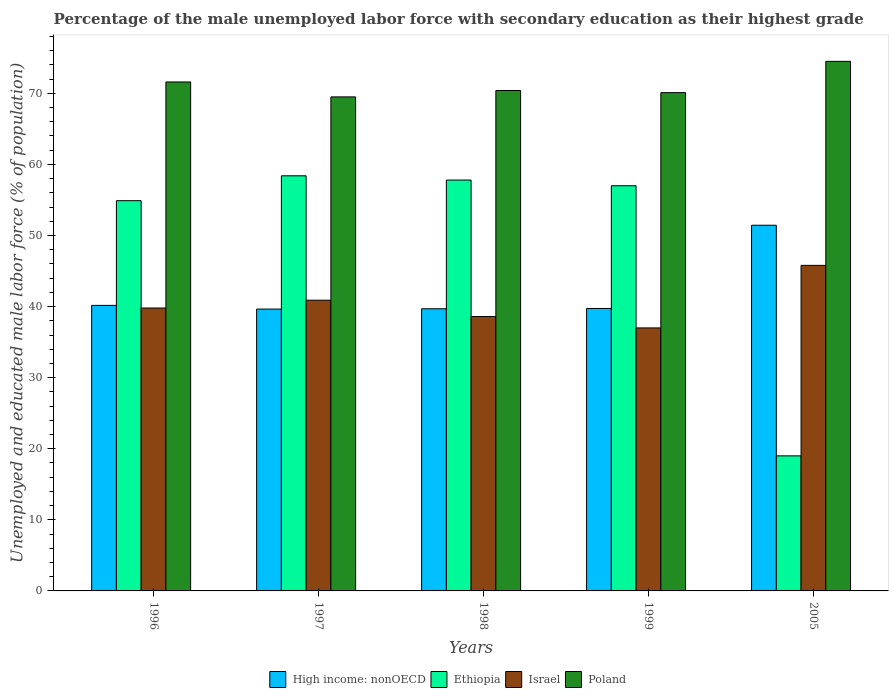Are the number of bars per tick equal to the number of legend labels?
Ensure brevity in your answer.  Yes. Are the number of bars on each tick of the X-axis equal?
Give a very brief answer. Yes. What is the label of the 2nd group of bars from the left?
Your answer should be very brief. 1997. In how many cases, is the number of bars for a given year not equal to the number of legend labels?
Make the answer very short. 0. What is the percentage of the unemployed male labor force with secondary education in High income: nonOECD in 1999?
Your answer should be compact. 39.74. Across all years, what is the maximum percentage of the unemployed male labor force with secondary education in Poland?
Keep it short and to the point. 74.5. Across all years, what is the minimum percentage of the unemployed male labor force with secondary education in Poland?
Provide a short and direct response. 69.5. In which year was the percentage of the unemployed male labor force with secondary education in Israel minimum?
Provide a succinct answer. 1999. What is the total percentage of the unemployed male labor force with secondary education in Ethiopia in the graph?
Your answer should be compact. 247.1. What is the difference between the percentage of the unemployed male labor force with secondary education in Ethiopia in 1997 and the percentage of the unemployed male labor force with secondary education in High income: nonOECD in 1998?
Provide a short and direct response. 18.7. What is the average percentage of the unemployed male labor force with secondary education in Ethiopia per year?
Your response must be concise. 49.42. In the year 1999, what is the difference between the percentage of the unemployed male labor force with secondary education in High income: nonOECD and percentage of the unemployed male labor force with secondary education in Poland?
Provide a succinct answer. -30.36. What is the ratio of the percentage of the unemployed male labor force with secondary education in High income: nonOECD in 1998 to that in 1999?
Your response must be concise. 1. What is the difference between the highest and the second highest percentage of the unemployed male labor force with secondary education in Poland?
Keep it short and to the point. 2.9. What is the difference between the highest and the lowest percentage of the unemployed male labor force with secondary education in High income: nonOECD?
Your answer should be compact. 11.8. What does the 2nd bar from the left in 1996 represents?
Give a very brief answer. Ethiopia. What does the 1st bar from the right in 2005 represents?
Offer a very short reply. Poland. Does the graph contain any zero values?
Your answer should be very brief. No. Does the graph contain grids?
Make the answer very short. No. Where does the legend appear in the graph?
Provide a succinct answer. Bottom center. What is the title of the graph?
Keep it short and to the point. Percentage of the male unemployed labor force with secondary education as their highest grade. Does "Venezuela" appear as one of the legend labels in the graph?
Offer a very short reply. No. What is the label or title of the X-axis?
Make the answer very short. Years. What is the label or title of the Y-axis?
Keep it short and to the point. Unemployed and educated male labor force (% of population). What is the Unemployed and educated male labor force (% of population) of High income: nonOECD in 1996?
Provide a short and direct response. 40.17. What is the Unemployed and educated male labor force (% of population) of Ethiopia in 1996?
Offer a terse response. 54.9. What is the Unemployed and educated male labor force (% of population) of Israel in 1996?
Give a very brief answer. 39.8. What is the Unemployed and educated male labor force (% of population) in Poland in 1996?
Your answer should be compact. 71.6. What is the Unemployed and educated male labor force (% of population) in High income: nonOECD in 1997?
Ensure brevity in your answer.  39.65. What is the Unemployed and educated male labor force (% of population) in Ethiopia in 1997?
Keep it short and to the point. 58.4. What is the Unemployed and educated male labor force (% of population) in Israel in 1997?
Your answer should be very brief. 40.9. What is the Unemployed and educated male labor force (% of population) of Poland in 1997?
Make the answer very short. 69.5. What is the Unemployed and educated male labor force (% of population) in High income: nonOECD in 1998?
Offer a very short reply. 39.7. What is the Unemployed and educated male labor force (% of population) of Ethiopia in 1998?
Make the answer very short. 57.8. What is the Unemployed and educated male labor force (% of population) in Israel in 1998?
Offer a very short reply. 38.6. What is the Unemployed and educated male labor force (% of population) in Poland in 1998?
Offer a terse response. 70.4. What is the Unemployed and educated male labor force (% of population) in High income: nonOECD in 1999?
Make the answer very short. 39.74. What is the Unemployed and educated male labor force (% of population) in Ethiopia in 1999?
Provide a succinct answer. 57. What is the Unemployed and educated male labor force (% of population) in Israel in 1999?
Your answer should be very brief. 37. What is the Unemployed and educated male labor force (% of population) in Poland in 1999?
Ensure brevity in your answer.  70.1. What is the Unemployed and educated male labor force (% of population) of High income: nonOECD in 2005?
Ensure brevity in your answer.  51.45. What is the Unemployed and educated male labor force (% of population) of Ethiopia in 2005?
Offer a terse response. 19. What is the Unemployed and educated male labor force (% of population) in Israel in 2005?
Your answer should be very brief. 45.8. What is the Unemployed and educated male labor force (% of population) of Poland in 2005?
Provide a succinct answer. 74.5. Across all years, what is the maximum Unemployed and educated male labor force (% of population) in High income: nonOECD?
Make the answer very short. 51.45. Across all years, what is the maximum Unemployed and educated male labor force (% of population) in Ethiopia?
Your answer should be compact. 58.4. Across all years, what is the maximum Unemployed and educated male labor force (% of population) in Israel?
Offer a very short reply. 45.8. Across all years, what is the maximum Unemployed and educated male labor force (% of population) in Poland?
Your answer should be very brief. 74.5. Across all years, what is the minimum Unemployed and educated male labor force (% of population) in High income: nonOECD?
Keep it short and to the point. 39.65. Across all years, what is the minimum Unemployed and educated male labor force (% of population) of Ethiopia?
Your answer should be compact. 19. Across all years, what is the minimum Unemployed and educated male labor force (% of population) of Israel?
Your response must be concise. 37. Across all years, what is the minimum Unemployed and educated male labor force (% of population) in Poland?
Ensure brevity in your answer.  69.5. What is the total Unemployed and educated male labor force (% of population) of High income: nonOECD in the graph?
Keep it short and to the point. 210.7. What is the total Unemployed and educated male labor force (% of population) of Ethiopia in the graph?
Make the answer very short. 247.1. What is the total Unemployed and educated male labor force (% of population) in Israel in the graph?
Keep it short and to the point. 202.1. What is the total Unemployed and educated male labor force (% of population) in Poland in the graph?
Make the answer very short. 356.1. What is the difference between the Unemployed and educated male labor force (% of population) of High income: nonOECD in 1996 and that in 1997?
Your answer should be compact. 0.52. What is the difference between the Unemployed and educated male labor force (% of population) in Israel in 1996 and that in 1997?
Your response must be concise. -1.1. What is the difference between the Unemployed and educated male labor force (% of population) in Poland in 1996 and that in 1997?
Provide a succinct answer. 2.1. What is the difference between the Unemployed and educated male labor force (% of population) of High income: nonOECD in 1996 and that in 1998?
Keep it short and to the point. 0.47. What is the difference between the Unemployed and educated male labor force (% of population) in Ethiopia in 1996 and that in 1998?
Keep it short and to the point. -2.9. What is the difference between the Unemployed and educated male labor force (% of population) in High income: nonOECD in 1996 and that in 1999?
Provide a succinct answer. 0.43. What is the difference between the Unemployed and educated male labor force (% of population) in Israel in 1996 and that in 1999?
Offer a very short reply. 2.8. What is the difference between the Unemployed and educated male labor force (% of population) of Poland in 1996 and that in 1999?
Your answer should be compact. 1.5. What is the difference between the Unemployed and educated male labor force (% of population) of High income: nonOECD in 1996 and that in 2005?
Your response must be concise. -11.28. What is the difference between the Unemployed and educated male labor force (% of population) in Ethiopia in 1996 and that in 2005?
Offer a terse response. 35.9. What is the difference between the Unemployed and educated male labor force (% of population) of Israel in 1996 and that in 2005?
Keep it short and to the point. -6. What is the difference between the Unemployed and educated male labor force (% of population) of Poland in 1996 and that in 2005?
Make the answer very short. -2.9. What is the difference between the Unemployed and educated male labor force (% of population) of High income: nonOECD in 1997 and that in 1998?
Keep it short and to the point. -0.04. What is the difference between the Unemployed and educated male labor force (% of population) in Ethiopia in 1997 and that in 1998?
Keep it short and to the point. 0.6. What is the difference between the Unemployed and educated male labor force (% of population) in Israel in 1997 and that in 1998?
Your answer should be very brief. 2.3. What is the difference between the Unemployed and educated male labor force (% of population) of Poland in 1997 and that in 1998?
Ensure brevity in your answer.  -0.9. What is the difference between the Unemployed and educated male labor force (% of population) of High income: nonOECD in 1997 and that in 1999?
Your answer should be compact. -0.09. What is the difference between the Unemployed and educated male labor force (% of population) in Israel in 1997 and that in 1999?
Offer a terse response. 3.9. What is the difference between the Unemployed and educated male labor force (% of population) in Poland in 1997 and that in 1999?
Provide a succinct answer. -0.6. What is the difference between the Unemployed and educated male labor force (% of population) of High income: nonOECD in 1997 and that in 2005?
Your response must be concise. -11.8. What is the difference between the Unemployed and educated male labor force (% of population) in Ethiopia in 1997 and that in 2005?
Offer a very short reply. 39.4. What is the difference between the Unemployed and educated male labor force (% of population) of Israel in 1997 and that in 2005?
Your answer should be compact. -4.9. What is the difference between the Unemployed and educated male labor force (% of population) of Poland in 1997 and that in 2005?
Give a very brief answer. -5. What is the difference between the Unemployed and educated male labor force (% of population) of High income: nonOECD in 1998 and that in 1999?
Your answer should be very brief. -0.04. What is the difference between the Unemployed and educated male labor force (% of population) in High income: nonOECD in 1998 and that in 2005?
Your response must be concise. -11.75. What is the difference between the Unemployed and educated male labor force (% of population) of Ethiopia in 1998 and that in 2005?
Offer a terse response. 38.8. What is the difference between the Unemployed and educated male labor force (% of population) in Israel in 1998 and that in 2005?
Provide a succinct answer. -7.2. What is the difference between the Unemployed and educated male labor force (% of population) in Poland in 1998 and that in 2005?
Offer a very short reply. -4.1. What is the difference between the Unemployed and educated male labor force (% of population) of High income: nonOECD in 1999 and that in 2005?
Give a very brief answer. -11.71. What is the difference between the Unemployed and educated male labor force (% of population) in Ethiopia in 1999 and that in 2005?
Give a very brief answer. 38. What is the difference between the Unemployed and educated male labor force (% of population) in Israel in 1999 and that in 2005?
Your response must be concise. -8.8. What is the difference between the Unemployed and educated male labor force (% of population) in High income: nonOECD in 1996 and the Unemployed and educated male labor force (% of population) in Ethiopia in 1997?
Offer a terse response. -18.23. What is the difference between the Unemployed and educated male labor force (% of population) in High income: nonOECD in 1996 and the Unemployed and educated male labor force (% of population) in Israel in 1997?
Provide a short and direct response. -0.73. What is the difference between the Unemployed and educated male labor force (% of population) of High income: nonOECD in 1996 and the Unemployed and educated male labor force (% of population) of Poland in 1997?
Your answer should be very brief. -29.33. What is the difference between the Unemployed and educated male labor force (% of population) in Ethiopia in 1996 and the Unemployed and educated male labor force (% of population) in Poland in 1997?
Give a very brief answer. -14.6. What is the difference between the Unemployed and educated male labor force (% of population) in Israel in 1996 and the Unemployed and educated male labor force (% of population) in Poland in 1997?
Offer a terse response. -29.7. What is the difference between the Unemployed and educated male labor force (% of population) in High income: nonOECD in 1996 and the Unemployed and educated male labor force (% of population) in Ethiopia in 1998?
Offer a very short reply. -17.63. What is the difference between the Unemployed and educated male labor force (% of population) in High income: nonOECD in 1996 and the Unemployed and educated male labor force (% of population) in Israel in 1998?
Give a very brief answer. 1.57. What is the difference between the Unemployed and educated male labor force (% of population) in High income: nonOECD in 1996 and the Unemployed and educated male labor force (% of population) in Poland in 1998?
Provide a succinct answer. -30.23. What is the difference between the Unemployed and educated male labor force (% of population) in Ethiopia in 1996 and the Unemployed and educated male labor force (% of population) in Poland in 1998?
Make the answer very short. -15.5. What is the difference between the Unemployed and educated male labor force (% of population) of Israel in 1996 and the Unemployed and educated male labor force (% of population) of Poland in 1998?
Give a very brief answer. -30.6. What is the difference between the Unemployed and educated male labor force (% of population) of High income: nonOECD in 1996 and the Unemployed and educated male labor force (% of population) of Ethiopia in 1999?
Your response must be concise. -16.83. What is the difference between the Unemployed and educated male labor force (% of population) in High income: nonOECD in 1996 and the Unemployed and educated male labor force (% of population) in Israel in 1999?
Your response must be concise. 3.17. What is the difference between the Unemployed and educated male labor force (% of population) in High income: nonOECD in 1996 and the Unemployed and educated male labor force (% of population) in Poland in 1999?
Provide a succinct answer. -29.93. What is the difference between the Unemployed and educated male labor force (% of population) in Ethiopia in 1996 and the Unemployed and educated male labor force (% of population) in Israel in 1999?
Offer a very short reply. 17.9. What is the difference between the Unemployed and educated male labor force (% of population) of Ethiopia in 1996 and the Unemployed and educated male labor force (% of population) of Poland in 1999?
Provide a short and direct response. -15.2. What is the difference between the Unemployed and educated male labor force (% of population) in Israel in 1996 and the Unemployed and educated male labor force (% of population) in Poland in 1999?
Your answer should be very brief. -30.3. What is the difference between the Unemployed and educated male labor force (% of population) in High income: nonOECD in 1996 and the Unemployed and educated male labor force (% of population) in Ethiopia in 2005?
Your response must be concise. 21.17. What is the difference between the Unemployed and educated male labor force (% of population) in High income: nonOECD in 1996 and the Unemployed and educated male labor force (% of population) in Israel in 2005?
Your answer should be very brief. -5.63. What is the difference between the Unemployed and educated male labor force (% of population) in High income: nonOECD in 1996 and the Unemployed and educated male labor force (% of population) in Poland in 2005?
Offer a terse response. -34.33. What is the difference between the Unemployed and educated male labor force (% of population) in Ethiopia in 1996 and the Unemployed and educated male labor force (% of population) in Israel in 2005?
Keep it short and to the point. 9.1. What is the difference between the Unemployed and educated male labor force (% of population) of Ethiopia in 1996 and the Unemployed and educated male labor force (% of population) of Poland in 2005?
Offer a very short reply. -19.6. What is the difference between the Unemployed and educated male labor force (% of population) in Israel in 1996 and the Unemployed and educated male labor force (% of population) in Poland in 2005?
Provide a succinct answer. -34.7. What is the difference between the Unemployed and educated male labor force (% of population) of High income: nonOECD in 1997 and the Unemployed and educated male labor force (% of population) of Ethiopia in 1998?
Ensure brevity in your answer.  -18.15. What is the difference between the Unemployed and educated male labor force (% of population) of High income: nonOECD in 1997 and the Unemployed and educated male labor force (% of population) of Israel in 1998?
Your response must be concise. 1.05. What is the difference between the Unemployed and educated male labor force (% of population) of High income: nonOECD in 1997 and the Unemployed and educated male labor force (% of population) of Poland in 1998?
Your answer should be compact. -30.75. What is the difference between the Unemployed and educated male labor force (% of population) of Ethiopia in 1997 and the Unemployed and educated male labor force (% of population) of Israel in 1998?
Offer a very short reply. 19.8. What is the difference between the Unemployed and educated male labor force (% of population) of Israel in 1997 and the Unemployed and educated male labor force (% of population) of Poland in 1998?
Your response must be concise. -29.5. What is the difference between the Unemployed and educated male labor force (% of population) of High income: nonOECD in 1997 and the Unemployed and educated male labor force (% of population) of Ethiopia in 1999?
Keep it short and to the point. -17.35. What is the difference between the Unemployed and educated male labor force (% of population) of High income: nonOECD in 1997 and the Unemployed and educated male labor force (% of population) of Israel in 1999?
Offer a very short reply. 2.65. What is the difference between the Unemployed and educated male labor force (% of population) in High income: nonOECD in 1997 and the Unemployed and educated male labor force (% of population) in Poland in 1999?
Provide a short and direct response. -30.45. What is the difference between the Unemployed and educated male labor force (% of population) in Ethiopia in 1997 and the Unemployed and educated male labor force (% of population) in Israel in 1999?
Give a very brief answer. 21.4. What is the difference between the Unemployed and educated male labor force (% of population) in Israel in 1997 and the Unemployed and educated male labor force (% of population) in Poland in 1999?
Provide a succinct answer. -29.2. What is the difference between the Unemployed and educated male labor force (% of population) of High income: nonOECD in 1997 and the Unemployed and educated male labor force (% of population) of Ethiopia in 2005?
Offer a terse response. 20.65. What is the difference between the Unemployed and educated male labor force (% of population) of High income: nonOECD in 1997 and the Unemployed and educated male labor force (% of population) of Israel in 2005?
Your response must be concise. -6.15. What is the difference between the Unemployed and educated male labor force (% of population) of High income: nonOECD in 1997 and the Unemployed and educated male labor force (% of population) of Poland in 2005?
Your answer should be compact. -34.85. What is the difference between the Unemployed and educated male labor force (% of population) of Ethiopia in 1997 and the Unemployed and educated male labor force (% of population) of Poland in 2005?
Make the answer very short. -16.1. What is the difference between the Unemployed and educated male labor force (% of population) of Israel in 1997 and the Unemployed and educated male labor force (% of population) of Poland in 2005?
Your answer should be very brief. -33.6. What is the difference between the Unemployed and educated male labor force (% of population) of High income: nonOECD in 1998 and the Unemployed and educated male labor force (% of population) of Ethiopia in 1999?
Your response must be concise. -17.3. What is the difference between the Unemployed and educated male labor force (% of population) of High income: nonOECD in 1998 and the Unemployed and educated male labor force (% of population) of Israel in 1999?
Ensure brevity in your answer.  2.7. What is the difference between the Unemployed and educated male labor force (% of population) in High income: nonOECD in 1998 and the Unemployed and educated male labor force (% of population) in Poland in 1999?
Make the answer very short. -30.4. What is the difference between the Unemployed and educated male labor force (% of population) in Ethiopia in 1998 and the Unemployed and educated male labor force (% of population) in Israel in 1999?
Your response must be concise. 20.8. What is the difference between the Unemployed and educated male labor force (% of population) in Israel in 1998 and the Unemployed and educated male labor force (% of population) in Poland in 1999?
Ensure brevity in your answer.  -31.5. What is the difference between the Unemployed and educated male labor force (% of population) in High income: nonOECD in 1998 and the Unemployed and educated male labor force (% of population) in Ethiopia in 2005?
Your answer should be compact. 20.7. What is the difference between the Unemployed and educated male labor force (% of population) in High income: nonOECD in 1998 and the Unemployed and educated male labor force (% of population) in Israel in 2005?
Ensure brevity in your answer.  -6.1. What is the difference between the Unemployed and educated male labor force (% of population) of High income: nonOECD in 1998 and the Unemployed and educated male labor force (% of population) of Poland in 2005?
Your response must be concise. -34.8. What is the difference between the Unemployed and educated male labor force (% of population) of Ethiopia in 1998 and the Unemployed and educated male labor force (% of population) of Poland in 2005?
Provide a succinct answer. -16.7. What is the difference between the Unemployed and educated male labor force (% of population) of Israel in 1998 and the Unemployed and educated male labor force (% of population) of Poland in 2005?
Offer a terse response. -35.9. What is the difference between the Unemployed and educated male labor force (% of population) of High income: nonOECD in 1999 and the Unemployed and educated male labor force (% of population) of Ethiopia in 2005?
Provide a short and direct response. 20.74. What is the difference between the Unemployed and educated male labor force (% of population) in High income: nonOECD in 1999 and the Unemployed and educated male labor force (% of population) in Israel in 2005?
Offer a very short reply. -6.06. What is the difference between the Unemployed and educated male labor force (% of population) of High income: nonOECD in 1999 and the Unemployed and educated male labor force (% of population) of Poland in 2005?
Keep it short and to the point. -34.76. What is the difference between the Unemployed and educated male labor force (% of population) in Ethiopia in 1999 and the Unemployed and educated male labor force (% of population) in Poland in 2005?
Offer a very short reply. -17.5. What is the difference between the Unemployed and educated male labor force (% of population) in Israel in 1999 and the Unemployed and educated male labor force (% of population) in Poland in 2005?
Give a very brief answer. -37.5. What is the average Unemployed and educated male labor force (% of population) of High income: nonOECD per year?
Provide a short and direct response. 42.14. What is the average Unemployed and educated male labor force (% of population) of Ethiopia per year?
Provide a short and direct response. 49.42. What is the average Unemployed and educated male labor force (% of population) of Israel per year?
Your answer should be very brief. 40.42. What is the average Unemployed and educated male labor force (% of population) of Poland per year?
Your answer should be very brief. 71.22. In the year 1996, what is the difference between the Unemployed and educated male labor force (% of population) of High income: nonOECD and Unemployed and educated male labor force (% of population) of Ethiopia?
Provide a succinct answer. -14.73. In the year 1996, what is the difference between the Unemployed and educated male labor force (% of population) of High income: nonOECD and Unemployed and educated male labor force (% of population) of Israel?
Offer a very short reply. 0.37. In the year 1996, what is the difference between the Unemployed and educated male labor force (% of population) in High income: nonOECD and Unemployed and educated male labor force (% of population) in Poland?
Keep it short and to the point. -31.43. In the year 1996, what is the difference between the Unemployed and educated male labor force (% of population) of Ethiopia and Unemployed and educated male labor force (% of population) of Poland?
Ensure brevity in your answer.  -16.7. In the year 1996, what is the difference between the Unemployed and educated male labor force (% of population) of Israel and Unemployed and educated male labor force (% of population) of Poland?
Your response must be concise. -31.8. In the year 1997, what is the difference between the Unemployed and educated male labor force (% of population) of High income: nonOECD and Unemployed and educated male labor force (% of population) of Ethiopia?
Keep it short and to the point. -18.75. In the year 1997, what is the difference between the Unemployed and educated male labor force (% of population) of High income: nonOECD and Unemployed and educated male labor force (% of population) of Israel?
Your answer should be very brief. -1.25. In the year 1997, what is the difference between the Unemployed and educated male labor force (% of population) of High income: nonOECD and Unemployed and educated male labor force (% of population) of Poland?
Your response must be concise. -29.85. In the year 1997, what is the difference between the Unemployed and educated male labor force (% of population) in Israel and Unemployed and educated male labor force (% of population) in Poland?
Give a very brief answer. -28.6. In the year 1998, what is the difference between the Unemployed and educated male labor force (% of population) of High income: nonOECD and Unemployed and educated male labor force (% of population) of Ethiopia?
Provide a short and direct response. -18.1. In the year 1998, what is the difference between the Unemployed and educated male labor force (% of population) in High income: nonOECD and Unemployed and educated male labor force (% of population) in Israel?
Your response must be concise. 1.1. In the year 1998, what is the difference between the Unemployed and educated male labor force (% of population) in High income: nonOECD and Unemployed and educated male labor force (% of population) in Poland?
Your answer should be very brief. -30.7. In the year 1998, what is the difference between the Unemployed and educated male labor force (% of population) of Ethiopia and Unemployed and educated male labor force (% of population) of Poland?
Offer a very short reply. -12.6. In the year 1998, what is the difference between the Unemployed and educated male labor force (% of population) of Israel and Unemployed and educated male labor force (% of population) of Poland?
Offer a very short reply. -31.8. In the year 1999, what is the difference between the Unemployed and educated male labor force (% of population) of High income: nonOECD and Unemployed and educated male labor force (% of population) of Ethiopia?
Offer a terse response. -17.26. In the year 1999, what is the difference between the Unemployed and educated male labor force (% of population) in High income: nonOECD and Unemployed and educated male labor force (% of population) in Israel?
Ensure brevity in your answer.  2.74. In the year 1999, what is the difference between the Unemployed and educated male labor force (% of population) of High income: nonOECD and Unemployed and educated male labor force (% of population) of Poland?
Your answer should be compact. -30.36. In the year 1999, what is the difference between the Unemployed and educated male labor force (% of population) in Ethiopia and Unemployed and educated male labor force (% of population) in Israel?
Your answer should be compact. 20. In the year 1999, what is the difference between the Unemployed and educated male labor force (% of population) of Israel and Unemployed and educated male labor force (% of population) of Poland?
Keep it short and to the point. -33.1. In the year 2005, what is the difference between the Unemployed and educated male labor force (% of population) in High income: nonOECD and Unemployed and educated male labor force (% of population) in Ethiopia?
Your response must be concise. 32.45. In the year 2005, what is the difference between the Unemployed and educated male labor force (% of population) in High income: nonOECD and Unemployed and educated male labor force (% of population) in Israel?
Provide a short and direct response. 5.65. In the year 2005, what is the difference between the Unemployed and educated male labor force (% of population) in High income: nonOECD and Unemployed and educated male labor force (% of population) in Poland?
Keep it short and to the point. -23.05. In the year 2005, what is the difference between the Unemployed and educated male labor force (% of population) of Ethiopia and Unemployed and educated male labor force (% of population) of Israel?
Offer a very short reply. -26.8. In the year 2005, what is the difference between the Unemployed and educated male labor force (% of population) in Ethiopia and Unemployed and educated male labor force (% of population) in Poland?
Provide a succinct answer. -55.5. In the year 2005, what is the difference between the Unemployed and educated male labor force (% of population) in Israel and Unemployed and educated male labor force (% of population) in Poland?
Offer a very short reply. -28.7. What is the ratio of the Unemployed and educated male labor force (% of population) in High income: nonOECD in 1996 to that in 1997?
Offer a very short reply. 1.01. What is the ratio of the Unemployed and educated male labor force (% of population) in Ethiopia in 1996 to that in 1997?
Keep it short and to the point. 0.94. What is the ratio of the Unemployed and educated male labor force (% of population) in Israel in 1996 to that in 1997?
Your answer should be very brief. 0.97. What is the ratio of the Unemployed and educated male labor force (% of population) in Poland in 1996 to that in 1997?
Make the answer very short. 1.03. What is the ratio of the Unemployed and educated male labor force (% of population) of High income: nonOECD in 1996 to that in 1998?
Offer a very short reply. 1.01. What is the ratio of the Unemployed and educated male labor force (% of population) of Ethiopia in 1996 to that in 1998?
Offer a very short reply. 0.95. What is the ratio of the Unemployed and educated male labor force (% of population) of Israel in 1996 to that in 1998?
Ensure brevity in your answer.  1.03. What is the ratio of the Unemployed and educated male labor force (% of population) in High income: nonOECD in 1996 to that in 1999?
Ensure brevity in your answer.  1.01. What is the ratio of the Unemployed and educated male labor force (% of population) of Ethiopia in 1996 to that in 1999?
Provide a short and direct response. 0.96. What is the ratio of the Unemployed and educated male labor force (% of population) of Israel in 1996 to that in 1999?
Your answer should be compact. 1.08. What is the ratio of the Unemployed and educated male labor force (% of population) of Poland in 1996 to that in 1999?
Provide a short and direct response. 1.02. What is the ratio of the Unemployed and educated male labor force (% of population) in High income: nonOECD in 1996 to that in 2005?
Your answer should be compact. 0.78. What is the ratio of the Unemployed and educated male labor force (% of population) of Ethiopia in 1996 to that in 2005?
Ensure brevity in your answer.  2.89. What is the ratio of the Unemployed and educated male labor force (% of population) of Israel in 1996 to that in 2005?
Provide a short and direct response. 0.87. What is the ratio of the Unemployed and educated male labor force (% of population) in Poland in 1996 to that in 2005?
Your response must be concise. 0.96. What is the ratio of the Unemployed and educated male labor force (% of population) of High income: nonOECD in 1997 to that in 1998?
Offer a very short reply. 1. What is the ratio of the Unemployed and educated male labor force (% of population) in Ethiopia in 1997 to that in 1998?
Provide a short and direct response. 1.01. What is the ratio of the Unemployed and educated male labor force (% of population) of Israel in 1997 to that in 1998?
Offer a terse response. 1.06. What is the ratio of the Unemployed and educated male labor force (% of population) in Poland in 1997 to that in 1998?
Offer a terse response. 0.99. What is the ratio of the Unemployed and educated male labor force (% of population) of High income: nonOECD in 1997 to that in 1999?
Ensure brevity in your answer.  1. What is the ratio of the Unemployed and educated male labor force (% of population) of Ethiopia in 1997 to that in 1999?
Offer a terse response. 1.02. What is the ratio of the Unemployed and educated male labor force (% of population) in Israel in 1997 to that in 1999?
Your answer should be very brief. 1.11. What is the ratio of the Unemployed and educated male labor force (% of population) in High income: nonOECD in 1997 to that in 2005?
Ensure brevity in your answer.  0.77. What is the ratio of the Unemployed and educated male labor force (% of population) in Ethiopia in 1997 to that in 2005?
Your answer should be compact. 3.07. What is the ratio of the Unemployed and educated male labor force (% of population) of Israel in 1997 to that in 2005?
Offer a very short reply. 0.89. What is the ratio of the Unemployed and educated male labor force (% of population) in Poland in 1997 to that in 2005?
Offer a terse response. 0.93. What is the ratio of the Unemployed and educated male labor force (% of population) in High income: nonOECD in 1998 to that in 1999?
Your answer should be very brief. 1. What is the ratio of the Unemployed and educated male labor force (% of population) in Israel in 1998 to that in 1999?
Your answer should be compact. 1.04. What is the ratio of the Unemployed and educated male labor force (% of population) of High income: nonOECD in 1998 to that in 2005?
Ensure brevity in your answer.  0.77. What is the ratio of the Unemployed and educated male labor force (% of population) of Ethiopia in 1998 to that in 2005?
Give a very brief answer. 3.04. What is the ratio of the Unemployed and educated male labor force (% of population) of Israel in 1998 to that in 2005?
Ensure brevity in your answer.  0.84. What is the ratio of the Unemployed and educated male labor force (% of population) of Poland in 1998 to that in 2005?
Your answer should be compact. 0.94. What is the ratio of the Unemployed and educated male labor force (% of population) of High income: nonOECD in 1999 to that in 2005?
Offer a very short reply. 0.77. What is the ratio of the Unemployed and educated male labor force (% of population) in Israel in 1999 to that in 2005?
Keep it short and to the point. 0.81. What is the ratio of the Unemployed and educated male labor force (% of population) of Poland in 1999 to that in 2005?
Keep it short and to the point. 0.94. What is the difference between the highest and the second highest Unemployed and educated male labor force (% of population) of High income: nonOECD?
Your answer should be very brief. 11.28. What is the difference between the highest and the second highest Unemployed and educated male labor force (% of population) in Ethiopia?
Provide a succinct answer. 0.6. What is the difference between the highest and the lowest Unemployed and educated male labor force (% of population) of High income: nonOECD?
Make the answer very short. 11.8. What is the difference between the highest and the lowest Unemployed and educated male labor force (% of population) in Ethiopia?
Your answer should be compact. 39.4. What is the difference between the highest and the lowest Unemployed and educated male labor force (% of population) in Israel?
Your answer should be very brief. 8.8. What is the difference between the highest and the lowest Unemployed and educated male labor force (% of population) in Poland?
Keep it short and to the point. 5. 